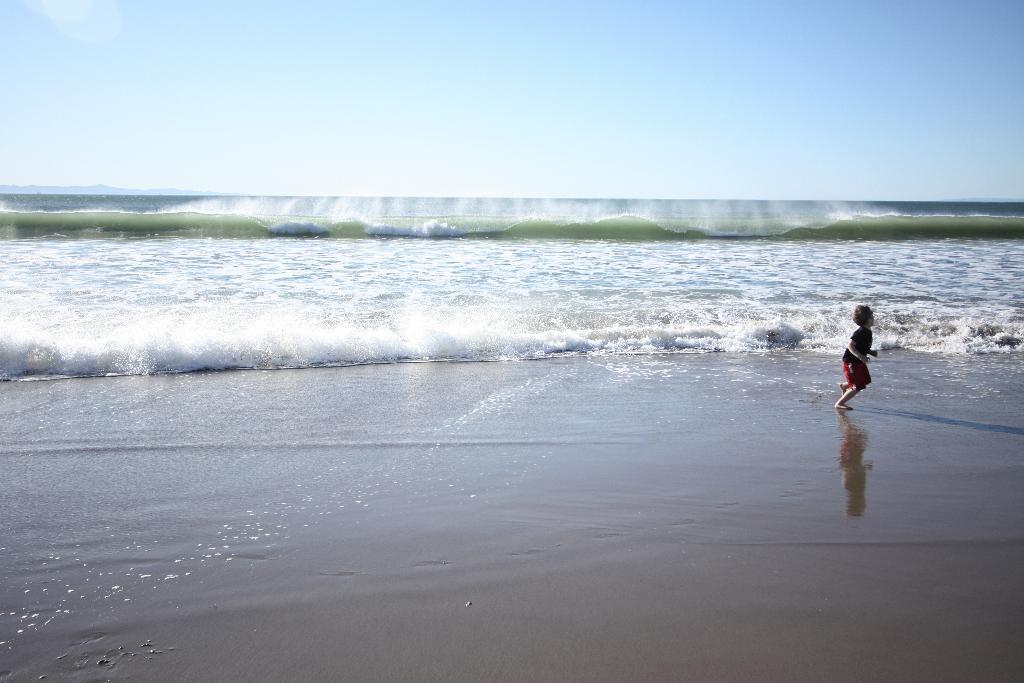What is the main subject of the image? There is a kid in the image. What is the kid doing in the image? The kid is running in the water. What can be seen in the background of the image? There is an ocean visible in the background of the image. What type of knowledge is the kid gaining from the gate in the image? There is no gate present in the image, so the kid cannot gain knowledge from it. 